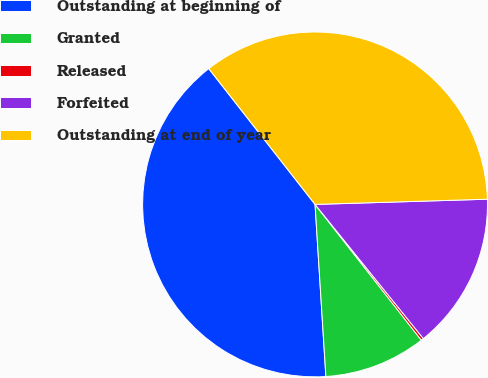Convert chart to OTSL. <chart><loc_0><loc_0><loc_500><loc_500><pie_chart><fcel>Outstanding at beginning of<fcel>Granted<fcel>Released<fcel>Forfeited<fcel>Outstanding at end of year<nl><fcel>40.43%<fcel>9.57%<fcel>0.24%<fcel>14.67%<fcel>35.09%<nl></chart> 